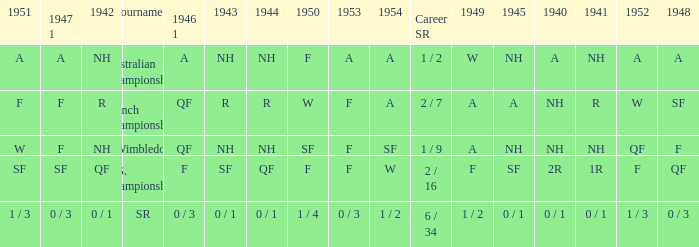What is the tournament that had a result of A in 1954 and NH in 1942? Australian Championships. 